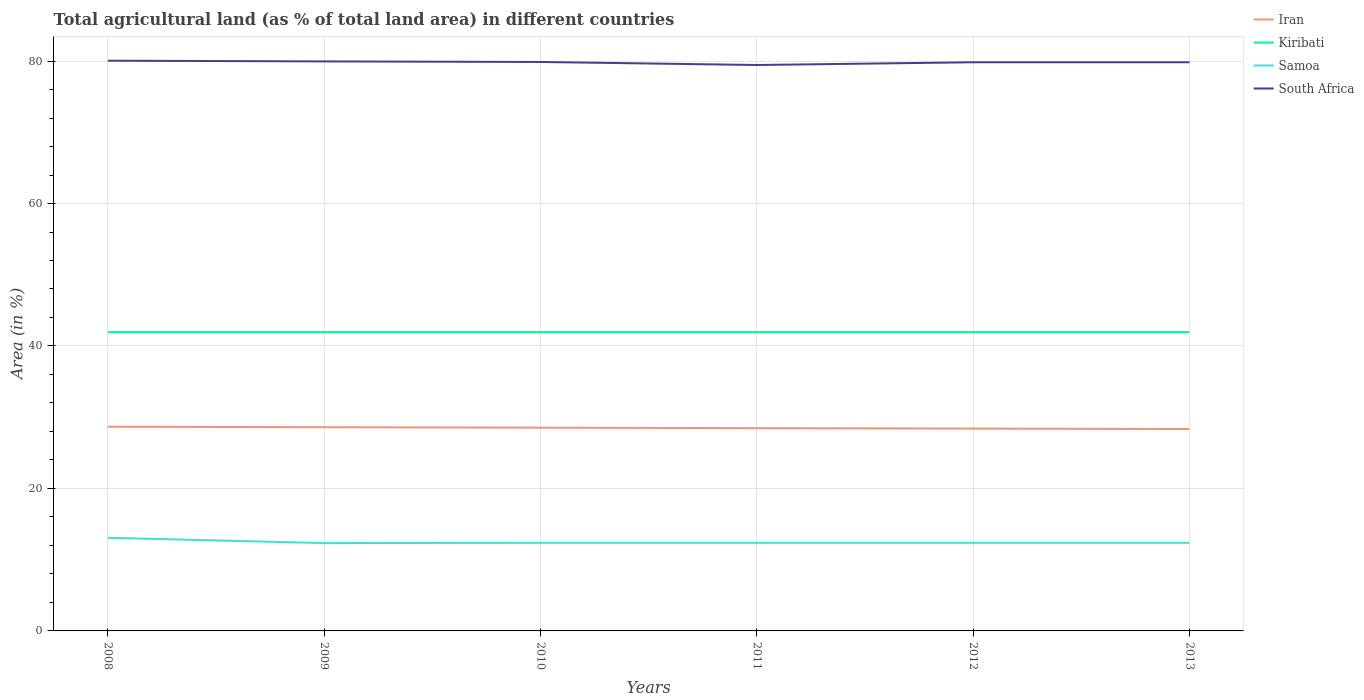How many different coloured lines are there?
Offer a very short reply. 4. Is the number of lines equal to the number of legend labels?
Keep it short and to the point. Yes. Across all years, what is the maximum percentage of agricultural land in Kiribati?
Your answer should be compact. 41.98. What is the total percentage of agricultural land in Kiribati in the graph?
Ensure brevity in your answer.  0. What is the difference between the highest and the second highest percentage of agricultural land in Kiribati?
Ensure brevity in your answer.  0. What is the difference between the highest and the lowest percentage of agricultural land in Samoa?
Keep it short and to the point. 1. How many lines are there?
Make the answer very short. 4. How many years are there in the graph?
Provide a succinct answer. 6. Are the values on the major ticks of Y-axis written in scientific E-notation?
Keep it short and to the point. No. How many legend labels are there?
Your answer should be very brief. 4. How are the legend labels stacked?
Offer a terse response. Vertical. What is the title of the graph?
Offer a very short reply. Total agricultural land (as % of total land area) in different countries. Does "Samoa" appear as one of the legend labels in the graph?
Make the answer very short. Yes. What is the label or title of the Y-axis?
Provide a succinct answer. Area (in %). What is the Area (in %) of Iran in 2008?
Provide a short and direct response. 28.67. What is the Area (in %) of Kiribati in 2008?
Give a very brief answer. 41.98. What is the Area (in %) in Samoa in 2008?
Your answer should be very brief. 13.07. What is the Area (in %) of South Africa in 2008?
Offer a terse response. 80.05. What is the Area (in %) in Iran in 2009?
Your response must be concise. 28.6. What is the Area (in %) in Kiribati in 2009?
Your response must be concise. 41.98. What is the Area (in %) in Samoa in 2009?
Your response must be concise. 12.33. What is the Area (in %) of South Africa in 2009?
Your response must be concise. 79.95. What is the Area (in %) of Iran in 2010?
Ensure brevity in your answer.  28.53. What is the Area (in %) of Kiribati in 2010?
Make the answer very short. 41.98. What is the Area (in %) in Samoa in 2010?
Give a very brief answer. 12.37. What is the Area (in %) of South Africa in 2010?
Offer a terse response. 79.87. What is the Area (in %) of Iran in 2011?
Give a very brief answer. 28.47. What is the Area (in %) of Kiribati in 2011?
Offer a terse response. 41.98. What is the Area (in %) in Samoa in 2011?
Ensure brevity in your answer.  12.37. What is the Area (in %) of South Africa in 2011?
Ensure brevity in your answer.  79.45. What is the Area (in %) in Iran in 2012?
Your answer should be compact. 28.41. What is the Area (in %) of Kiribati in 2012?
Your response must be concise. 41.98. What is the Area (in %) in Samoa in 2012?
Make the answer very short. 12.37. What is the Area (in %) of South Africa in 2012?
Your answer should be compact. 79.83. What is the Area (in %) of Iran in 2013?
Offer a terse response. 28.34. What is the Area (in %) of Kiribati in 2013?
Your answer should be very brief. 41.98. What is the Area (in %) of Samoa in 2013?
Make the answer very short. 12.37. What is the Area (in %) in South Africa in 2013?
Your answer should be very brief. 79.83. Across all years, what is the maximum Area (in %) in Iran?
Your answer should be very brief. 28.67. Across all years, what is the maximum Area (in %) of Kiribati?
Give a very brief answer. 41.98. Across all years, what is the maximum Area (in %) in Samoa?
Provide a short and direct response. 13.07. Across all years, what is the maximum Area (in %) in South Africa?
Offer a terse response. 80.05. Across all years, what is the minimum Area (in %) of Iran?
Ensure brevity in your answer.  28.34. Across all years, what is the minimum Area (in %) of Kiribati?
Your answer should be very brief. 41.98. Across all years, what is the minimum Area (in %) of Samoa?
Your answer should be compact. 12.33. Across all years, what is the minimum Area (in %) in South Africa?
Offer a very short reply. 79.45. What is the total Area (in %) in Iran in the graph?
Your answer should be compact. 171.01. What is the total Area (in %) of Kiribati in the graph?
Give a very brief answer. 251.85. What is the total Area (in %) of Samoa in the graph?
Make the answer very short. 74.88. What is the total Area (in %) in South Africa in the graph?
Offer a very short reply. 478.98. What is the difference between the Area (in %) of Iran in 2008 and that in 2009?
Give a very brief answer. 0.07. What is the difference between the Area (in %) of Kiribati in 2008 and that in 2009?
Give a very brief answer. 0. What is the difference between the Area (in %) in Samoa in 2008 and that in 2009?
Offer a very short reply. 0.74. What is the difference between the Area (in %) of South Africa in 2008 and that in 2009?
Make the answer very short. 0.1. What is the difference between the Area (in %) in Iran in 2008 and that in 2010?
Ensure brevity in your answer.  0.13. What is the difference between the Area (in %) of Samoa in 2008 and that in 2010?
Offer a very short reply. 0.71. What is the difference between the Area (in %) in South Africa in 2008 and that in 2010?
Ensure brevity in your answer.  0.18. What is the difference between the Area (in %) of Iran in 2008 and that in 2011?
Your response must be concise. 0.2. What is the difference between the Area (in %) of Kiribati in 2008 and that in 2011?
Your answer should be compact. 0. What is the difference between the Area (in %) of Samoa in 2008 and that in 2011?
Make the answer very short. 0.71. What is the difference between the Area (in %) in South Africa in 2008 and that in 2011?
Your response must be concise. 0.61. What is the difference between the Area (in %) in Iran in 2008 and that in 2012?
Keep it short and to the point. 0.26. What is the difference between the Area (in %) in Samoa in 2008 and that in 2012?
Ensure brevity in your answer.  0.71. What is the difference between the Area (in %) of South Africa in 2008 and that in 2012?
Your answer should be compact. 0.22. What is the difference between the Area (in %) in Iran in 2008 and that in 2013?
Make the answer very short. 0.32. What is the difference between the Area (in %) in Kiribati in 2008 and that in 2013?
Make the answer very short. 0. What is the difference between the Area (in %) of Samoa in 2008 and that in 2013?
Your response must be concise. 0.71. What is the difference between the Area (in %) in South Africa in 2008 and that in 2013?
Your response must be concise. 0.22. What is the difference between the Area (in %) of Iran in 2009 and that in 2010?
Provide a succinct answer. 0.06. What is the difference between the Area (in %) of Kiribati in 2009 and that in 2010?
Keep it short and to the point. 0. What is the difference between the Area (in %) of Samoa in 2009 and that in 2010?
Offer a terse response. -0.04. What is the difference between the Area (in %) in South Africa in 2009 and that in 2010?
Your answer should be compact. 0.08. What is the difference between the Area (in %) in Iran in 2009 and that in 2011?
Make the answer very short. 0.13. What is the difference between the Area (in %) in Samoa in 2009 and that in 2011?
Offer a terse response. -0.04. What is the difference between the Area (in %) in South Africa in 2009 and that in 2011?
Offer a very short reply. 0.51. What is the difference between the Area (in %) of Iran in 2009 and that in 2012?
Provide a succinct answer. 0.19. What is the difference between the Area (in %) of Kiribati in 2009 and that in 2012?
Provide a succinct answer. 0. What is the difference between the Area (in %) in Samoa in 2009 and that in 2012?
Provide a short and direct response. -0.04. What is the difference between the Area (in %) of South Africa in 2009 and that in 2012?
Offer a very short reply. 0.12. What is the difference between the Area (in %) of Iran in 2009 and that in 2013?
Keep it short and to the point. 0.25. What is the difference between the Area (in %) in Kiribati in 2009 and that in 2013?
Keep it short and to the point. 0. What is the difference between the Area (in %) of Samoa in 2009 and that in 2013?
Give a very brief answer. -0.04. What is the difference between the Area (in %) of South Africa in 2009 and that in 2013?
Your answer should be very brief. 0.12. What is the difference between the Area (in %) of Iran in 2010 and that in 2011?
Provide a short and direct response. 0.07. What is the difference between the Area (in %) in Kiribati in 2010 and that in 2011?
Provide a short and direct response. 0. What is the difference between the Area (in %) in South Africa in 2010 and that in 2011?
Keep it short and to the point. 0.43. What is the difference between the Area (in %) in Iran in 2010 and that in 2012?
Keep it short and to the point. 0.13. What is the difference between the Area (in %) in South Africa in 2010 and that in 2012?
Your response must be concise. 0.04. What is the difference between the Area (in %) of Iran in 2010 and that in 2013?
Offer a terse response. 0.19. What is the difference between the Area (in %) in Kiribati in 2010 and that in 2013?
Make the answer very short. 0. What is the difference between the Area (in %) of South Africa in 2010 and that in 2013?
Your response must be concise. 0.04. What is the difference between the Area (in %) of Iran in 2011 and that in 2012?
Offer a very short reply. 0.06. What is the difference between the Area (in %) in Samoa in 2011 and that in 2012?
Offer a terse response. 0. What is the difference between the Area (in %) of South Africa in 2011 and that in 2012?
Your answer should be very brief. -0.39. What is the difference between the Area (in %) of Iran in 2011 and that in 2013?
Provide a short and direct response. 0.12. What is the difference between the Area (in %) in Kiribati in 2011 and that in 2013?
Your answer should be very brief. 0. What is the difference between the Area (in %) of South Africa in 2011 and that in 2013?
Provide a short and direct response. -0.39. What is the difference between the Area (in %) of Iran in 2012 and that in 2013?
Your answer should be compact. 0.06. What is the difference between the Area (in %) in Samoa in 2012 and that in 2013?
Your answer should be very brief. 0. What is the difference between the Area (in %) in South Africa in 2012 and that in 2013?
Ensure brevity in your answer.  0. What is the difference between the Area (in %) in Iran in 2008 and the Area (in %) in Kiribati in 2009?
Your answer should be very brief. -13.31. What is the difference between the Area (in %) in Iran in 2008 and the Area (in %) in Samoa in 2009?
Offer a terse response. 16.33. What is the difference between the Area (in %) of Iran in 2008 and the Area (in %) of South Africa in 2009?
Ensure brevity in your answer.  -51.28. What is the difference between the Area (in %) in Kiribati in 2008 and the Area (in %) in Samoa in 2009?
Your answer should be compact. 29.64. What is the difference between the Area (in %) in Kiribati in 2008 and the Area (in %) in South Africa in 2009?
Your response must be concise. -37.98. What is the difference between the Area (in %) in Samoa in 2008 and the Area (in %) in South Africa in 2009?
Ensure brevity in your answer.  -66.88. What is the difference between the Area (in %) in Iran in 2008 and the Area (in %) in Kiribati in 2010?
Make the answer very short. -13.31. What is the difference between the Area (in %) in Iran in 2008 and the Area (in %) in Samoa in 2010?
Give a very brief answer. 16.3. What is the difference between the Area (in %) in Iran in 2008 and the Area (in %) in South Africa in 2010?
Ensure brevity in your answer.  -51.2. What is the difference between the Area (in %) of Kiribati in 2008 and the Area (in %) of Samoa in 2010?
Give a very brief answer. 29.61. What is the difference between the Area (in %) in Kiribati in 2008 and the Area (in %) in South Africa in 2010?
Offer a terse response. -37.9. What is the difference between the Area (in %) of Samoa in 2008 and the Area (in %) of South Africa in 2010?
Keep it short and to the point. -66.8. What is the difference between the Area (in %) of Iran in 2008 and the Area (in %) of Kiribati in 2011?
Provide a succinct answer. -13.31. What is the difference between the Area (in %) of Iran in 2008 and the Area (in %) of Samoa in 2011?
Offer a very short reply. 16.3. What is the difference between the Area (in %) of Iran in 2008 and the Area (in %) of South Africa in 2011?
Your response must be concise. -50.78. What is the difference between the Area (in %) of Kiribati in 2008 and the Area (in %) of Samoa in 2011?
Give a very brief answer. 29.61. What is the difference between the Area (in %) in Kiribati in 2008 and the Area (in %) in South Africa in 2011?
Make the answer very short. -37.47. What is the difference between the Area (in %) of Samoa in 2008 and the Area (in %) of South Africa in 2011?
Your answer should be very brief. -66.37. What is the difference between the Area (in %) of Iran in 2008 and the Area (in %) of Kiribati in 2012?
Your answer should be compact. -13.31. What is the difference between the Area (in %) of Iran in 2008 and the Area (in %) of Samoa in 2012?
Keep it short and to the point. 16.3. What is the difference between the Area (in %) of Iran in 2008 and the Area (in %) of South Africa in 2012?
Make the answer very short. -51.16. What is the difference between the Area (in %) of Kiribati in 2008 and the Area (in %) of Samoa in 2012?
Provide a short and direct response. 29.61. What is the difference between the Area (in %) in Kiribati in 2008 and the Area (in %) in South Africa in 2012?
Give a very brief answer. -37.85. What is the difference between the Area (in %) of Samoa in 2008 and the Area (in %) of South Africa in 2012?
Make the answer very short. -66.76. What is the difference between the Area (in %) of Iran in 2008 and the Area (in %) of Kiribati in 2013?
Ensure brevity in your answer.  -13.31. What is the difference between the Area (in %) in Iran in 2008 and the Area (in %) in Samoa in 2013?
Offer a terse response. 16.3. What is the difference between the Area (in %) in Iran in 2008 and the Area (in %) in South Africa in 2013?
Provide a succinct answer. -51.16. What is the difference between the Area (in %) of Kiribati in 2008 and the Area (in %) of Samoa in 2013?
Keep it short and to the point. 29.61. What is the difference between the Area (in %) of Kiribati in 2008 and the Area (in %) of South Africa in 2013?
Make the answer very short. -37.85. What is the difference between the Area (in %) in Samoa in 2008 and the Area (in %) in South Africa in 2013?
Keep it short and to the point. -66.76. What is the difference between the Area (in %) of Iran in 2009 and the Area (in %) of Kiribati in 2010?
Provide a succinct answer. -13.38. What is the difference between the Area (in %) in Iran in 2009 and the Area (in %) in Samoa in 2010?
Your answer should be very brief. 16.23. What is the difference between the Area (in %) of Iran in 2009 and the Area (in %) of South Africa in 2010?
Provide a succinct answer. -51.27. What is the difference between the Area (in %) of Kiribati in 2009 and the Area (in %) of Samoa in 2010?
Make the answer very short. 29.61. What is the difference between the Area (in %) in Kiribati in 2009 and the Area (in %) in South Africa in 2010?
Offer a very short reply. -37.9. What is the difference between the Area (in %) of Samoa in 2009 and the Area (in %) of South Africa in 2010?
Provide a succinct answer. -67.54. What is the difference between the Area (in %) in Iran in 2009 and the Area (in %) in Kiribati in 2011?
Your response must be concise. -13.38. What is the difference between the Area (in %) in Iran in 2009 and the Area (in %) in Samoa in 2011?
Ensure brevity in your answer.  16.23. What is the difference between the Area (in %) of Iran in 2009 and the Area (in %) of South Africa in 2011?
Make the answer very short. -50.85. What is the difference between the Area (in %) of Kiribati in 2009 and the Area (in %) of Samoa in 2011?
Give a very brief answer. 29.61. What is the difference between the Area (in %) in Kiribati in 2009 and the Area (in %) in South Africa in 2011?
Offer a terse response. -37.47. What is the difference between the Area (in %) in Samoa in 2009 and the Area (in %) in South Africa in 2011?
Provide a short and direct response. -67.11. What is the difference between the Area (in %) in Iran in 2009 and the Area (in %) in Kiribati in 2012?
Ensure brevity in your answer.  -13.38. What is the difference between the Area (in %) of Iran in 2009 and the Area (in %) of Samoa in 2012?
Provide a short and direct response. 16.23. What is the difference between the Area (in %) in Iran in 2009 and the Area (in %) in South Africa in 2012?
Offer a very short reply. -51.23. What is the difference between the Area (in %) of Kiribati in 2009 and the Area (in %) of Samoa in 2012?
Keep it short and to the point. 29.61. What is the difference between the Area (in %) of Kiribati in 2009 and the Area (in %) of South Africa in 2012?
Give a very brief answer. -37.85. What is the difference between the Area (in %) of Samoa in 2009 and the Area (in %) of South Africa in 2012?
Your response must be concise. -67.5. What is the difference between the Area (in %) of Iran in 2009 and the Area (in %) of Kiribati in 2013?
Ensure brevity in your answer.  -13.38. What is the difference between the Area (in %) of Iran in 2009 and the Area (in %) of Samoa in 2013?
Provide a short and direct response. 16.23. What is the difference between the Area (in %) of Iran in 2009 and the Area (in %) of South Africa in 2013?
Offer a very short reply. -51.23. What is the difference between the Area (in %) of Kiribati in 2009 and the Area (in %) of Samoa in 2013?
Give a very brief answer. 29.61. What is the difference between the Area (in %) of Kiribati in 2009 and the Area (in %) of South Africa in 2013?
Make the answer very short. -37.85. What is the difference between the Area (in %) in Samoa in 2009 and the Area (in %) in South Africa in 2013?
Offer a very short reply. -67.5. What is the difference between the Area (in %) of Iran in 2010 and the Area (in %) of Kiribati in 2011?
Your answer should be compact. -13.44. What is the difference between the Area (in %) of Iran in 2010 and the Area (in %) of Samoa in 2011?
Your answer should be compact. 16.17. What is the difference between the Area (in %) in Iran in 2010 and the Area (in %) in South Africa in 2011?
Offer a very short reply. -50.91. What is the difference between the Area (in %) of Kiribati in 2010 and the Area (in %) of Samoa in 2011?
Your response must be concise. 29.61. What is the difference between the Area (in %) of Kiribati in 2010 and the Area (in %) of South Africa in 2011?
Your response must be concise. -37.47. What is the difference between the Area (in %) of Samoa in 2010 and the Area (in %) of South Africa in 2011?
Offer a terse response. -67.08. What is the difference between the Area (in %) in Iran in 2010 and the Area (in %) in Kiribati in 2012?
Ensure brevity in your answer.  -13.44. What is the difference between the Area (in %) of Iran in 2010 and the Area (in %) of Samoa in 2012?
Offer a terse response. 16.17. What is the difference between the Area (in %) in Iran in 2010 and the Area (in %) in South Africa in 2012?
Give a very brief answer. -51.3. What is the difference between the Area (in %) in Kiribati in 2010 and the Area (in %) in Samoa in 2012?
Your answer should be very brief. 29.61. What is the difference between the Area (in %) of Kiribati in 2010 and the Area (in %) of South Africa in 2012?
Give a very brief answer. -37.85. What is the difference between the Area (in %) of Samoa in 2010 and the Area (in %) of South Africa in 2012?
Ensure brevity in your answer.  -67.46. What is the difference between the Area (in %) of Iran in 2010 and the Area (in %) of Kiribati in 2013?
Your response must be concise. -13.44. What is the difference between the Area (in %) in Iran in 2010 and the Area (in %) in Samoa in 2013?
Your answer should be very brief. 16.17. What is the difference between the Area (in %) of Iran in 2010 and the Area (in %) of South Africa in 2013?
Your answer should be compact. -51.3. What is the difference between the Area (in %) in Kiribati in 2010 and the Area (in %) in Samoa in 2013?
Provide a short and direct response. 29.61. What is the difference between the Area (in %) in Kiribati in 2010 and the Area (in %) in South Africa in 2013?
Offer a terse response. -37.85. What is the difference between the Area (in %) of Samoa in 2010 and the Area (in %) of South Africa in 2013?
Offer a terse response. -67.46. What is the difference between the Area (in %) in Iran in 2011 and the Area (in %) in Kiribati in 2012?
Keep it short and to the point. -13.51. What is the difference between the Area (in %) in Iran in 2011 and the Area (in %) in Samoa in 2012?
Provide a succinct answer. 16.1. What is the difference between the Area (in %) of Iran in 2011 and the Area (in %) of South Africa in 2012?
Ensure brevity in your answer.  -51.36. What is the difference between the Area (in %) of Kiribati in 2011 and the Area (in %) of Samoa in 2012?
Your answer should be very brief. 29.61. What is the difference between the Area (in %) of Kiribati in 2011 and the Area (in %) of South Africa in 2012?
Your response must be concise. -37.85. What is the difference between the Area (in %) in Samoa in 2011 and the Area (in %) in South Africa in 2012?
Your response must be concise. -67.46. What is the difference between the Area (in %) in Iran in 2011 and the Area (in %) in Kiribati in 2013?
Ensure brevity in your answer.  -13.51. What is the difference between the Area (in %) in Iran in 2011 and the Area (in %) in Samoa in 2013?
Ensure brevity in your answer.  16.1. What is the difference between the Area (in %) of Iran in 2011 and the Area (in %) of South Africa in 2013?
Ensure brevity in your answer.  -51.36. What is the difference between the Area (in %) in Kiribati in 2011 and the Area (in %) in Samoa in 2013?
Provide a succinct answer. 29.61. What is the difference between the Area (in %) in Kiribati in 2011 and the Area (in %) in South Africa in 2013?
Keep it short and to the point. -37.85. What is the difference between the Area (in %) in Samoa in 2011 and the Area (in %) in South Africa in 2013?
Ensure brevity in your answer.  -67.46. What is the difference between the Area (in %) in Iran in 2012 and the Area (in %) in Kiribati in 2013?
Give a very brief answer. -13.57. What is the difference between the Area (in %) of Iran in 2012 and the Area (in %) of Samoa in 2013?
Your response must be concise. 16.04. What is the difference between the Area (in %) in Iran in 2012 and the Area (in %) in South Africa in 2013?
Ensure brevity in your answer.  -51.42. What is the difference between the Area (in %) of Kiribati in 2012 and the Area (in %) of Samoa in 2013?
Your answer should be very brief. 29.61. What is the difference between the Area (in %) of Kiribati in 2012 and the Area (in %) of South Africa in 2013?
Offer a terse response. -37.85. What is the difference between the Area (in %) in Samoa in 2012 and the Area (in %) in South Africa in 2013?
Offer a very short reply. -67.46. What is the average Area (in %) in Iran per year?
Your answer should be compact. 28.5. What is the average Area (in %) of Kiribati per year?
Give a very brief answer. 41.98. What is the average Area (in %) of Samoa per year?
Make the answer very short. 12.48. What is the average Area (in %) of South Africa per year?
Provide a succinct answer. 79.83. In the year 2008, what is the difference between the Area (in %) of Iran and Area (in %) of Kiribati?
Make the answer very short. -13.31. In the year 2008, what is the difference between the Area (in %) of Iran and Area (in %) of Samoa?
Ensure brevity in your answer.  15.59. In the year 2008, what is the difference between the Area (in %) in Iran and Area (in %) in South Africa?
Provide a succinct answer. -51.38. In the year 2008, what is the difference between the Area (in %) of Kiribati and Area (in %) of Samoa?
Your answer should be compact. 28.9. In the year 2008, what is the difference between the Area (in %) in Kiribati and Area (in %) in South Africa?
Your answer should be compact. -38.07. In the year 2008, what is the difference between the Area (in %) in Samoa and Area (in %) in South Africa?
Make the answer very short. -66.98. In the year 2009, what is the difference between the Area (in %) of Iran and Area (in %) of Kiribati?
Offer a very short reply. -13.38. In the year 2009, what is the difference between the Area (in %) of Iran and Area (in %) of Samoa?
Ensure brevity in your answer.  16.27. In the year 2009, what is the difference between the Area (in %) of Iran and Area (in %) of South Africa?
Your answer should be compact. -51.35. In the year 2009, what is the difference between the Area (in %) of Kiribati and Area (in %) of Samoa?
Your answer should be compact. 29.64. In the year 2009, what is the difference between the Area (in %) in Kiribati and Area (in %) in South Africa?
Offer a terse response. -37.98. In the year 2009, what is the difference between the Area (in %) of Samoa and Area (in %) of South Africa?
Offer a terse response. -67.62. In the year 2010, what is the difference between the Area (in %) of Iran and Area (in %) of Kiribati?
Offer a terse response. -13.44. In the year 2010, what is the difference between the Area (in %) of Iran and Area (in %) of Samoa?
Provide a short and direct response. 16.17. In the year 2010, what is the difference between the Area (in %) of Iran and Area (in %) of South Africa?
Your answer should be compact. -51.34. In the year 2010, what is the difference between the Area (in %) of Kiribati and Area (in %) of Samoa?
Make the answer very short. 29.61. In the year 2010, what is the difference between the Area (in %) in Kiribati and Area (in %) in South Africa?
Give a very brief answer. -37.9. In the year 2010, what is the difference between the Area (in %) in Samoa and Area (in %) in South Africa?
Make the answer very short. -67.5. In the year 2011, what is the difference between the Area (in %) of Iran and Area (in %) of Kiribati?
Provide a short and direct response. -13.51. In the year 2011, what is the difference between the Area (in %) in Iran and Area (in %) in Samoa?
Keep it short and to the point. 16.1. In the year 2011, what is the difference between the Area (in %) of Iran and Area (in %) of South Africa?
Make the answer very short. -50.98. In the year 2011, what is the difference between the Area (in %) in Kiribati and Area (in %) in Samoa?
Your answer should be very brief. 29.61. In the year 2011, what is the difference between the Area (in %) of Kiribati and Area (in %) of South Africa?
Offer a very short reply. -37.47. In the year 2011, what is the difference between the Area (in %) in Samoa and Area (in %) in South Africa?
Your response must be concise. -67.08. In the year 2012, what is the difference between the Area (in %) in Iran and Area (in %) in Kiribati?
Your response must be concise. -13.57. In the year 2012, what is the difference between the Area (in %) of Iran and Area (in %) of Samoa?
Offer a very short reply. 16.04. In the year 2012, what is the difference between the Area (in %) of Iran and Area (in %) of South Africa?
Your response must be concise. -51.42. In the year 2012, what is the difference between the Area (in %) of Kiribati and Area (in %) of Samoa?
Provide a succinct answer. 29.61. In the year 2012, what is the difference between the Area (in %) of Kiribati and Area (in %) of South Africa?
Offer a terse response. -37.85. In the year 2012, what is the difference between the Area (in %) of Samoa and Area (in %) of South Africa?
Your response must be concise. -67.46. In the year 2013, what is the difference between the Area (in %) in Iran and Area (in %) in Kiribati?
Make the answer very short. -13.63. In the year 2013, what is the difference between the Area (in %) in Iran and Area (in %) in Samoa?
Provide a succinct answer. 15.98. In the year 2013, what is the difference between the Area (in %) of Iran and Area (in %) of South Africa?
Ensure brevity in your answer.  -51.49. In the year 2013, what is the difference between the Area (in %) of Kiribati and Area (in %) of Samoa?
Offer a very short reply. 29.61. In the year 2013, what is the difference between the Area (in %) in Kiribati and Area (in %) in South Africa?
Give a very brief answer. -37.85. In the year 2013, what is the difference between the Area (in %) in Samoa and Area (in %) in South Africa?
Make the answer very short. -67.46. What is the ratio of the Area (in %) in Iran in 2008 to that in 2009?
Ensure brevity in your answer.  1. What is the ratio of the Area (in %) in Kiribati in 2008 to that in 2009?
Ensure brevity in your answer.  1. What is the ratio of the Area (in %) of Samoa in 2008 to that in 2009?
Keep it short and to the point. 1.06. What is the ratio of the Area (in %) of Samoa in 2008 to that in 2010?
Give a very brief answer. 1.06. What is the ratio of the Area (in %) of Iran in 2008 to that in 2011?
Keep it short and to the point. 1.01. What is the ratio of the Area (in %) in Samoa in 2008 to that in 2011?
Offer a very short reply. 1.06. What is the ratio of the Area (in %) in South Africa in 2008 to that in 2011?
Provide a short and direct response. 1.01. What is the ratio of the Area (in %) of Iran in 2008 to that in 2012?
Ensure brevity in your answer.  1.01. What is the ratio of the Area (in %) of Samoa in 2008 to that in 2012?
Make the answer very short. 1.06. What is the ratio of the Area (in %) in Iran in 2008 to that in 2013?
Your response must be concise. 1.01. What is the ratio of the Area (in %) in Kiribati in 2008 to that in 2013?
Make the answer very short. 1. What is the ratio of the Area (in %) of Samoa in 2008 to that in 2013?
Offer a terse response. 1.06. What is the ratio of the Area (in %) of South Africa in 2008 to that in 2013?
Offer a very short reply. 1. What is the ratio of the Area (in %) in Iran in 2009 to that in 2010?
Ensure brevity in your answer.  1. What is the ratio of the Area (in %) of Kiribati in 2009 to that in 2010?
Ensure brevity in your answer.  1. What is the ratio of the Area (in %) of South Africa in 2009 to that in 2010?
Your answer should be compact. 1. What is the ratio of the Area (in %) of Kiribati in 2009 to that in 2011?
Keep it short and to the point. 1. What is the ratio of the Area (in %) of South Africa in 2009 to that in 2011?
Your answer should be compact. 1.01. What is the ratio of the Area (in %) in Kiribati in 2009 to that in 2012?
Your answer should be very brief. 1. What is the ratio of the Area (in %) of South Africa in 2009 to that in 2012?
Provide a short and direct response. 1. What is the ratio of the Area (in %) of Iran in 2009 to that in 2013?
Offer a very short reply. 1.01. What is the ratio of the Area (in %) in Samoa in 2009 to that in 2013?
Provide a succinct answer. 1. What is the ratio of the Area (in %) in Iran in 2010 to that in 2011?
Your answer should be very brief. 1. What is the ratio of the Area (in %) of Samoa in 2010 to that in 2011?
Ensure brevity in your answer.  1. What is the ratio of the Area (in %) of South Africa in 2010 to that in 2011?
Provide a short and direct response. 1.01. What is the ratio of the Area (in %) in Kiribati in 2010 to that in 2012?
Ensure brevity in your answer.  1. What is the ratio of the Area (in %) in Kiribati in 2010 to that in 2013?
Make the answer very short. 1. What is the ratio of the Area (in %) in Samoa in 2010 to that in 2013?
Ensure brevity in your answer.  1. What is the ratio of the Area (in %) of South Africa in 2010 to that in 2013?
Keep it short and to the point. 1. What is the ratio of the Area (in %) of Iran in 2011 to that in 2012?
Give a very brief answer. 1. What is the ratio of the Area (in %) of Samoa in 2011 to that in 2012?
Provide a succinct answer. 1. What is the ratio of the Area (in %) in Kiribati in 2011 to that in 2013?
Ensure brevity in your answer.  1. What is the ratio of the Area (in %) in Samoa in 2011 to that in 2013?
Offer a very short reply. 1. What is the ratio of the Area (in %) of South Africa in 2011 to that in 2013?
Ensure brevity in your answer.  1. What is the ratio of the Area (in %) in Iran in 2012 to that in 2013?
Your response must be concise. 1. What is the ratio of the Area (in %) in Kiribati in 2012 to that in 2013?
Ensure brevity in your answer.  1. What is the ratio of the Area (in %) in South Africa in 2012 to that in 2013?
Offer a very short reply. 1. What is the difference between the highest and the second highest Area (in %) in Iran?
Offer a very short reply. 0.07. What is the difference between the highest and the second highest Area (in %) of Kiribati?
Your answer should be compact. 0. What is the difference between the highest and the second highest Area (in %) in Samoa?
Make the answer very short. 0.71. What is the difference between the highest and the second highest Area (in %) of South Africa?
Provide a succinct answer. 0.1. What is the difference between the highest and the lowest Area (in %) of Iran?
Ensure brevity in your answer.  0.32. What is the difference between the highest and the lowest Area (in %) of Kiribati?
Make the answer very short. 0. What is the difference between the highest and the lowest Area (in %) in Samoa?
Your answer should be compact. 0.74. What is the difference between the highest and the lowest Area (in %) in South Africa?
Provide a short and direct response. 0.61. 